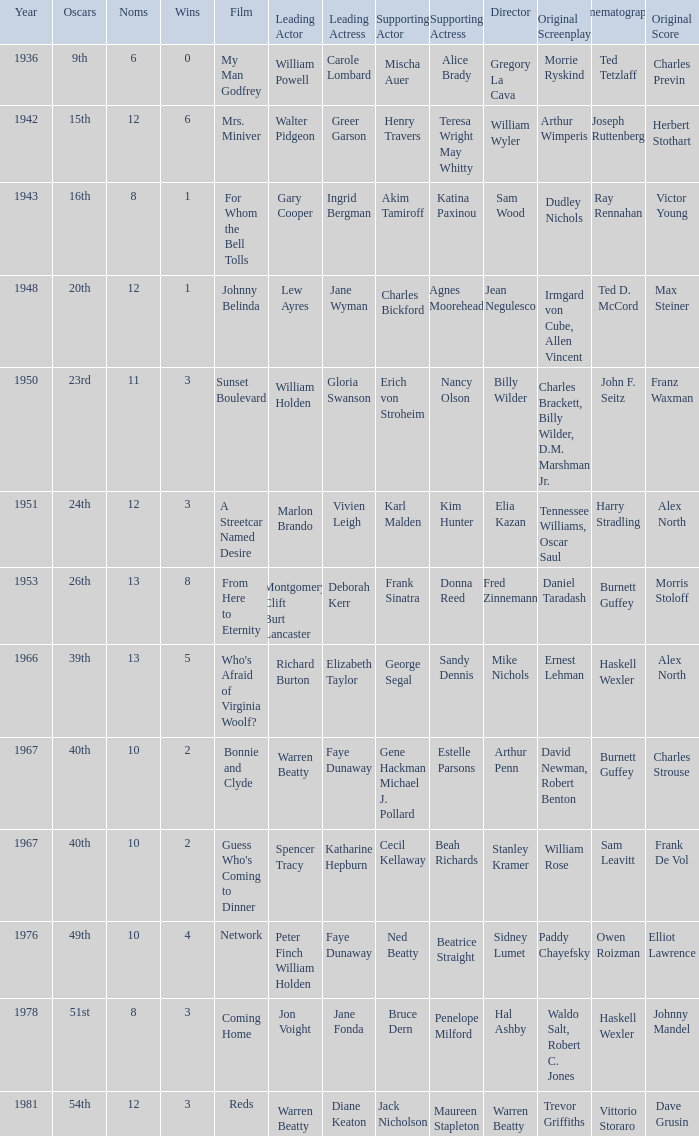Who was the supporting actress in "For Whom the Bell Tolls"? Katina Paxinou. Could you parse the entire table as a dict? {'header': ['Year', 'Oscars', 'Noms', 'Wins', 'Film', 'Leading Actor', 'Leading Actress', 'Supporting Actor', 'Supporting Actress', 'Director', 'Original Screenplay', 'Cinematography', 'Original Score'], 'rows': [['1936', '9th', '6', '0', 'My Man Godfrey', 'William Powell', 'Carole Lombard', 'Mischa Auer', 'Alice Brady', 'Gregory La Cava', 'Morrie Ryskind', 'Ted Tetzlaff', 'Charles Previn'], ['1942', '15th', '12', '6', 'Mrs. Miniver', 'Walter Pidgeon', 'Greer Garson', 'Henry Travers', 'Teresa Wright May Whitty', 'William Wyler', 'Arthur Wimperis', 'Joseph Ruttenberg', 'Herbert Stothart'], ['1943', '16th', '8', '1', 'For Whom the Bell Tolls', 'Gary Cooper', 'Ingrid Bergman', 'Akim Tamiroff', 'Katina Paxinou', 'Sam Wood', 'Dudley Nichols', 'Ray Rennahan', 'Victor Young'], ['1948', '20th', '12', '1', 'Johnny Belinda', 'Lew Ayres', 'Jane Wyman', 'Charles Bickford', 'Agnes Moorehead', 'Jean Negulesco', 'Irmgard von Cube, Allen Vincent', 'Ted D. McCord', 'Max Steiner'], ['1950', '23rd', '11', '3', 'Sunset Boulevard', 'William Holden', 'Gloria Swanson', 'Erich von Stroheim', 'Nancy Olson', 'Billy Wilder', 'Charles Brackett, Billy Wilder, D.M. Marshman Jr.', 'John F. Seitz', 'Franz Waxman'], ['1951', '24th', '12', '3', 'A Streetcar Named Desire', 'Marlon Brando', 'Vivien Leigh', 'Karl Malden', 'Kim Hunter', 'Elia Kazan', 'Tennessee Williams, Oscar Saul', 'Harry Stradling', 'Alex North'], ['1953', '26th', '13', '8', 'From Here to Eternity', 'Montgomery Clift Burt Lancaster', 'Deborah Kerr', 'Frank Sinatra', 'Donna Reed', 'Fred Zinnemann', 'Daniel Taradash', 'Burnett Guffey', 'Morris Stoloff'], ['1966', '39th', '13', '5', "Who's Afraid of Virginia Woolf?", 'Richard Burton', 'Elizabeth Taylor', 'George Segal', 'Sandy Dennis', 'Mike Nichols', 'Ernest Lehman', 'Haskell Wexler', 'Alex North'], ['1967', '40th', '10', '2', 'Bonnie and Clyde', 'Warren Beatty', 'Faye Dunaway', 'Gene Hackman Michael J. Pollard', 'Estelle Parsons', 'Arthur Penn', 'David Newman, Robert Benton', 'Burnett Guffey', 'Charles Strouse'], ['1967', '40th', '10', '2', "Guess Who's Coming to Dinner", 'Spencer Tracy', 'Katharine Hepburn', 'Cecil Kellaway', 'Beah Richards', 'Stanley Kramer', 'William Rose', 'Sam Leavitt', 'Frank De Vol'], ['1976', '49th', '10', '4', 'Network', 'Peter Finch William Holden', 'Faye Dunaway', 'Ned Beatty', 'Beatrice Straight', 'Sidney Lumet', 'Paddy Chayefsky', 'Owen Roizman', 'Elliot Lawrence'], ['1978', '51st', '8', '3', 'Coming Home', 'Jon Voight', 'Jane Fonda', 'Bruce Dern', 'Penelope Milford', 'Hal Ashby', 'Waldo Salt, Robert C. Jones', 'Haskell Wexler', 'Johnny Mandel'], ['1981', '54th', '12', '3', 'Reds', 'Warren Beatty', 'Diane Keaton', 'Jack Nicholson', 'Maureen Stapleton', 'Warren Beatty', 'Trevor Griffiths', 'Vittorio Storaro', 'Dave Grusin']]} 